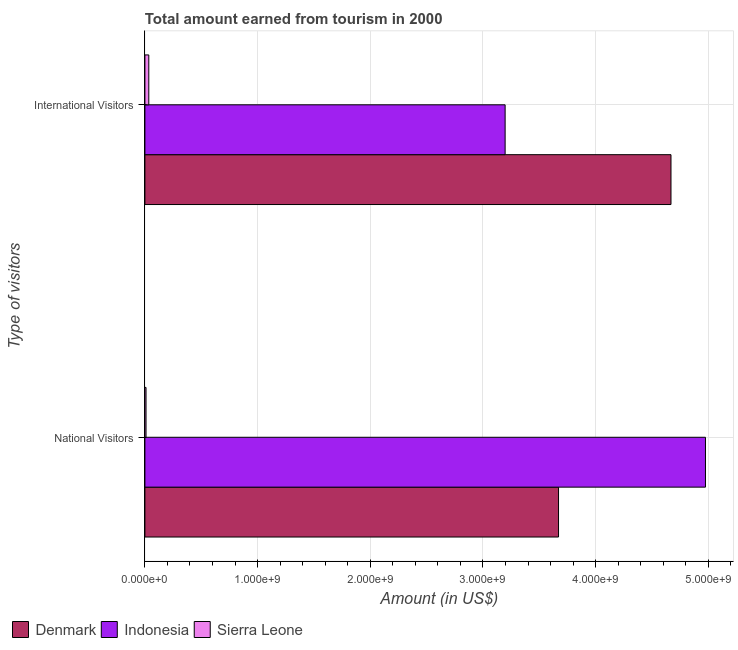How many groups of bars are there?
Provide a short and direct response. 2. Are the number of bars per tick equal to the number of legend labels?
Ensure brevity in your answer.  Yes. Are the number of bars on each tick of the Y-axis equal?
Offer a terse response. Yes. How many bars are there on the 2nd tick from the bottom?
Provide a short and direct response. 3. What is the label of the 2nd group of bars from the top?
Keep it short and to the point. National Visitors. What is the amount earned from international visitors in Indonesia?
Your answer should be very brief. 3.20e+09. Across all countries, what is the maximum amount earned from international visitors?
Offer a very short reply. 4.67e+09. Across all countries, what is the minimum amount earned from national visitors?
Your answer should be very brief. 1.00e+07. In which country was the amount earned from international visitors maximum?
Make the answer very short. Denmark. In which country was the amount earned from international visitors minimum?
Your answer should be very brief. Sierra Leone. What is the total amount earned from international visitors in the graph?
Provide a short and direct response. 7.90e+09. What is the difference between the amount earned from international visitors in Sierra Leone and that in Indonesia?
Offer a terse response. -3.16e+09. What is the difference between the amount earned from national visitors in Denmark and the amount earned from international visitors in Indonesia?
Give a very brief answer. 4.74e+08. What is the average amount earned from national visitors per country?
Your response must be concise. 2.89e+09. What is the difference between the amount earned from international visitors and amount earned from national visitors in Denmark?
Keep it short and to the point. 9.98e+08. What is the ratio of the amount earned from international visitors in Indonesia to that in Denmark?
Ensure brevity in your answer.  0.68. Is the amount earned from national visitors in Denmark less than that in Indonesia?
Your answer should be very brief. Yes. In how many countries, is the amount earned from national visitors greater than the average amount earned from national visitors taken over all countries?
Your answer should be compact. 2. How many bars are there?
Make the answer very short. 6. Are all the bars in the graph horizontal?
Offer a terse response. Yes. How many countries are there in the graph?
Your answer should be compact. 3. What is the difference between two consecutive major ticks on the X-axis?
Make the answer very short. 1.00e+09. Are the values on the major ticks of X-axis written in scientific E-notation?
Your response must be concise. Yes. Does the graph contain grids?
Give a very brief answer. Yes. How many legend labels are there?
Keep it short and to the point. 3. What is the title of the graph?
Offer a terse response. Total amount earned from tourism in 2000. Does "Iceland" appear as one of the legend labels in the graph?
Provide a succinct answer. No. What is the label or title of the Y-axis?
Provide a short and direct response. Type of visitors. What is the Amount (in US$) of Denmark in National Visitors?
Your answer should be very brief. 3.67e+09. What is the Amount (in US$) of Indonesia in National Visitors?
Your answer should be compact. 4.98e+09. What is the Amount (in US$) in Sierra Leone in National Visitors?
Offer a very short reply. 1.00e+07. What is the Amount (in US$) of Denmark in International Visitors?
Keep it short and to the point. 4.67e+09. What is the Amount (in US$) of Indonesia in International Visitors?
Your answer should be compact. 3.20e+09. What is the Amount (in US$) of Sierra Leone in International Visitors?
Provide a short and direct response. 3.45e+07. Across all Type of visitors, what is the maximum Amount (in US$) in Denmark?
Ensure brevity in your answer.  4.67e+09. Across all Type of visitors, what is the maximum Amount (in US$) in Indonesia?
Your response must be concise. 4.98e+09. Across all Type of visitors, what is the maximum Amount (in US$) in Sierra Leone?
Offer a very short reply. 3.45e+07. Across all Type of visitors, what is the minimum Amount (in US$) of Denmark?
Ensure brevity in your answer.  3.67e+09. Across all Type of visitors, what is the minimum Amount (in US$) in Indonesia?
Provide a short and direct response. 3.20e+09. Across all Type of visitors, what is the minimum Amount (in US$) of Sierra Leone?
Keep it short and to the point. 1.00e+07. What is the total Amount (in US$) in Denmark in the graph?
Your answer should be very brief. 8.34e+09. What is the total Amount (in US$) in Indonesia in the graph?
Offer a terse response. 8.17e+09. What is the total Amount (in US$) in Sierra Leone in the graph?
Keep it short and to the point. 4.45e+07. What is the difference between the Amount (in US$) in Denmark in National Visitors and that in International Visitors?
Your answer should be very brief. -9.98e+08. What is the difference between the Amount (in US$) of Indonesia in National Visitors and that in International Visitors?
Give a very brief answer. 1.78e+09. What is the difference between the Amount (in US$) in Sierra Leone in National Visitors and that in International Visitors?
Offer a very short reply. -2.45e+07. What is the difference between the Amount (in US$) in Denmark in National Visitors and the Amount (in US$) in Indonesia in International Visitors?
Keep it short and to the point. 4.74e+08. What is the difference between the Amount (in US$) of Denmark in National Visitors and the Amount (in US$) of Sierra Leone in International Visitors?
Offer a terse response. 3.64e+09. What is the difference between the Amount (in US$) of Indonesia in National Visitors and the Amount (in US$) of Sierra Leone in International Visitors?
Offer a terse response. 4.94e+09. What is the average Amount (in US$) in Denmark per Type of visitors?
Make the answer very short. 4.17e+09. What is the average Amount (in US$) in Indonesia per Type of visitors?
Your answer should be compact. 4.09e+09. What is the average Amount (in US$) in Sierra Leone per Type of visitors?
Your response must be concise. 2.22e+07. What is the difference between the Amount (in US$) of Denmark and Amount (in US$) of Indonesia in National Visitors?
Your response must be concise. -1.30e+09. What is the difference between the Amount (in US$) of Denmark and Amount (in US$) of Sierra Leone in National Visitors?
Keep it short and to the point. 3.66e+09. What is the difference between the Amount (in US$) in Indonesia and Amount (in US$) in Sierra Leone in National Visitors?
Provide a short and direct response. 4.96e+09. What is the difference between the Amount (in US$) in Denmark and Amount (in US$) in Indonesia in International Visitors?
Keep it short and to the point. 1.47e+09. What is the difference between the Amount (in US$) of Denmark and Amount (in US$) of Sierra Leone in International Visitors?
Keep it short and to the point. 4.63e+09. What is the difference between the Amount (in US$) of Indonesia and Amount (in US$) of Sierra Leone in International Visitors?
Offer a terse response. 3.16e+09. What is the ratio of the Amount (in US$) of Denmark in National Visitors to that in International Visitors?
Your response must be concise. 0.79. What is the ratio of the Amount (in US$) of Indonesia in National Visitors to that in International Visitors?
Your answer should be compact. 1.56. What is the ratio of the Amount (in US$) in Sierra Leone in National Visitors to that in International Visitors?
Offer a terse response. 0.29. What is the difference between the highest and the second highest Amount (in US$) of Denmark?
Keep it short and to the point. 9.98e+08. What is the difference between the highest and the second highest Amount (in US$) of Indonesia?
Your response must be concise. 1.78e+09. What is the difference between the highest and the second highest Amount (in US$) in Sierra Leone?
Offer a terse response. 2.45e+07. What is the difference between the highest and the lowest Amount (in US$) in Denmark?
Provide a succinct answer. 9.98e+08. What is the difference between the highest and the lowest Amount (in US$) in Indonesia?
Offer a terse response. 1.78e+09. What is the difference between the highest and the lowest Amount (in US$) of Sierra Leone?
Offer a terse response. 2.45e+07. 